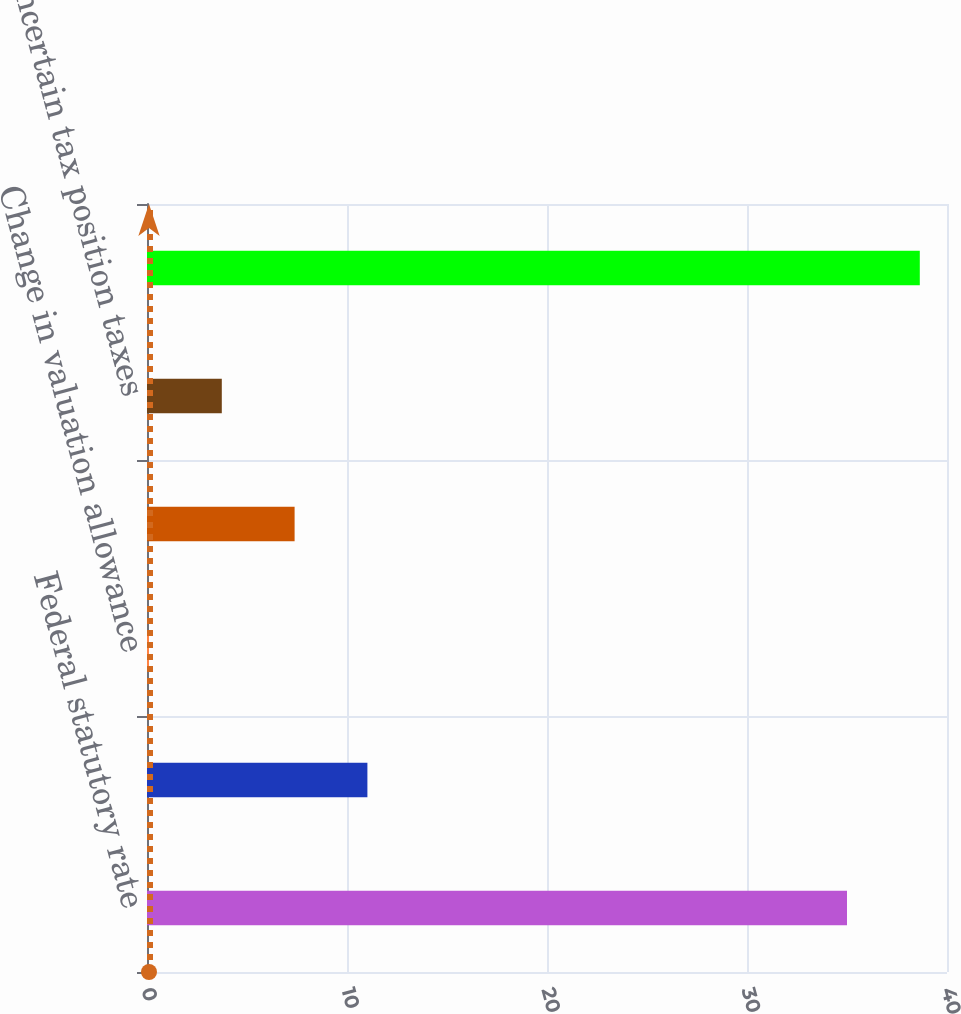Convert chart to OTSL. <chart><loc_0><loc_0><loc_500><loc_500><bar_chart><fcel>Federal statutory rate<fcel>State income taxes net of<fcel>Change in valuation allowance<fcel>Non-deductible expenses<fcel>Uncertain tax position taxes<fcel>Effective income tax rate<nl><fcel>35<fcel>11.02<fcel>0.1<fcel>7.38<fcel>3.74<fcel>38.64<nl></chart> 